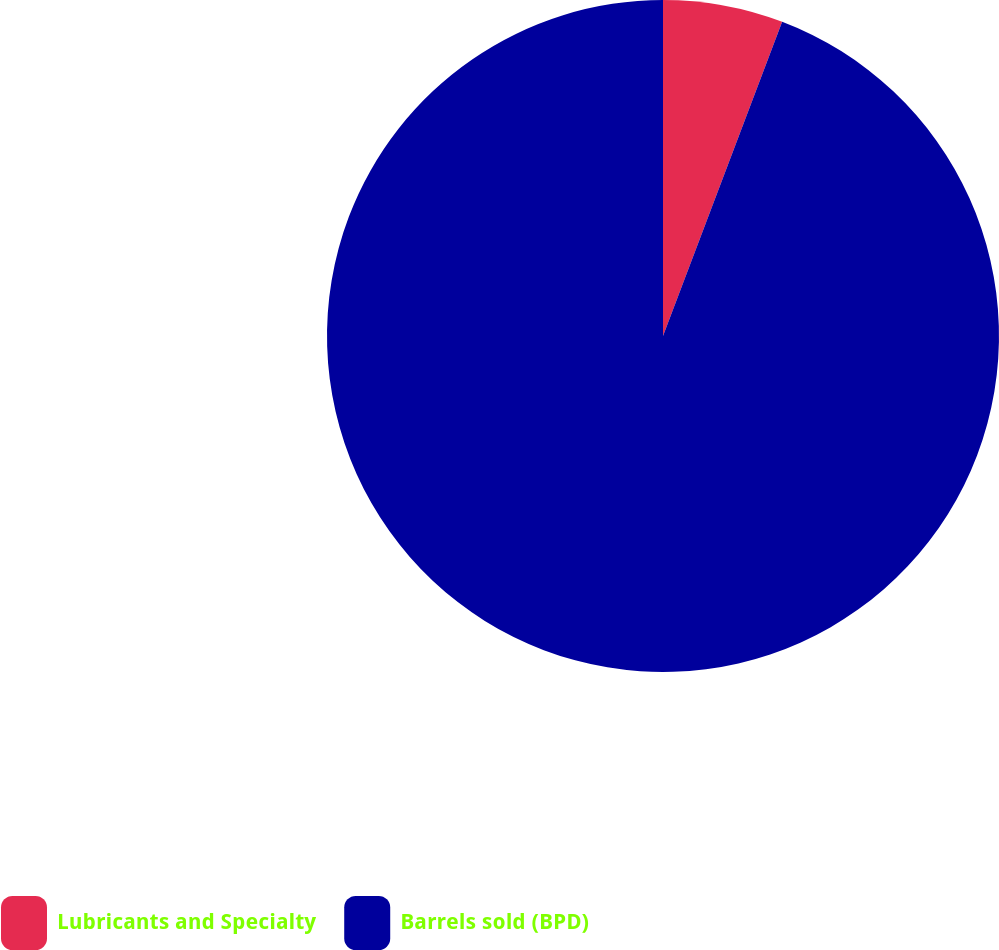Convert chart to OTSL. <chart><loc_0><loc_0><loc_500><loc_500><pie_chart><fcel>Lubricants and Specialty<fcel>Barrels sold (BPD)<nl><fcel>5.77%<fcel>94.23%<nl></chart> 